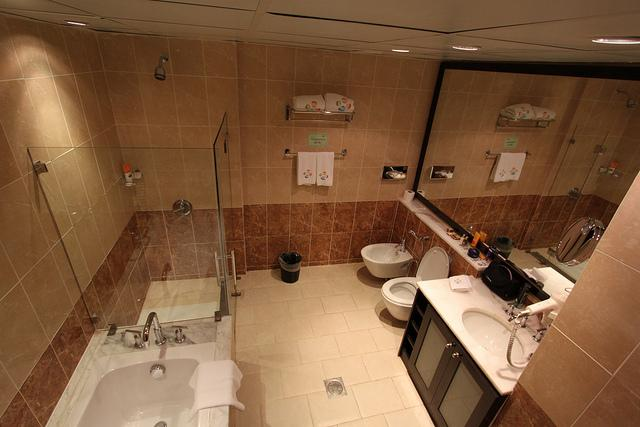What kind of bathroom is this?

Choices:
A) home
B) hotel
C) hospital
D) school hotel 